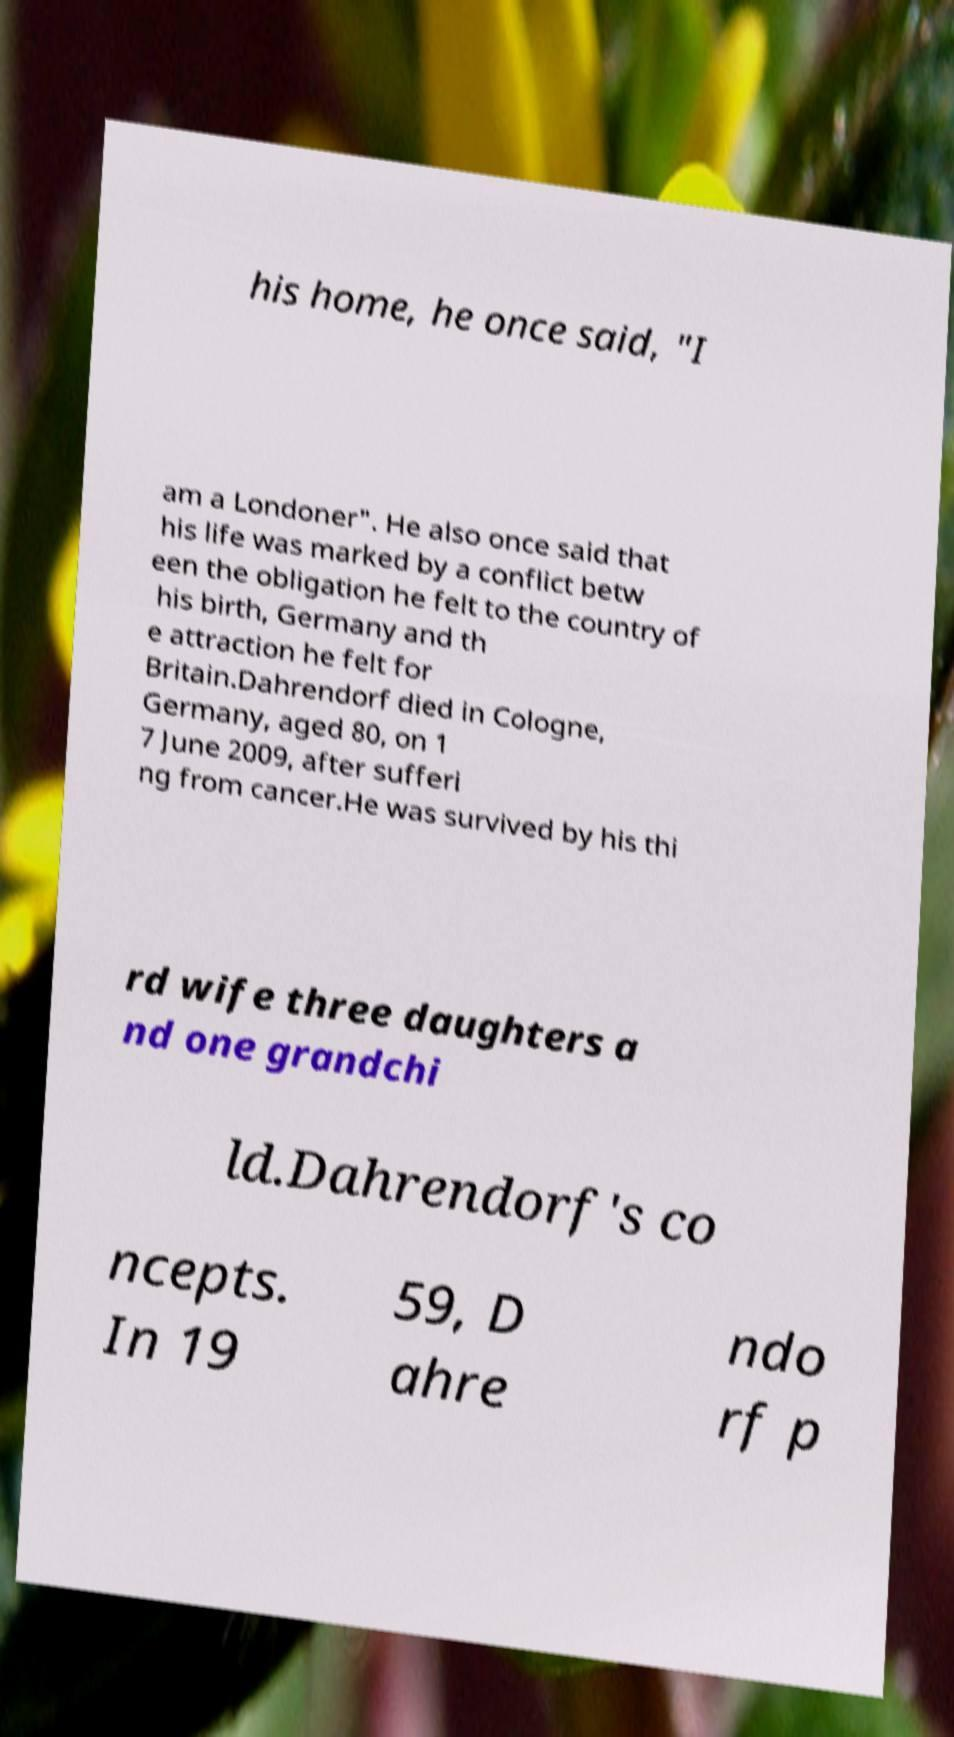There's text embedded in this image that I need extracted. Can you transcribe it verbatim? his home, he once said, "I am a Londoner". He also once said that his life was marked by a conflict betw een the obligation he felt to the country of his birth, Germany and th e attraction he felt for Britain.Dahrendorf died in Cologne, Germany, aged 80, on 1 7 June 2009, after sufferi ng from cancer.He was survived by his thi rd wife three daughters a nd one grandchi ld.Dahrendorf's co ncepts. In 19 59, D ahre ndo rf p 